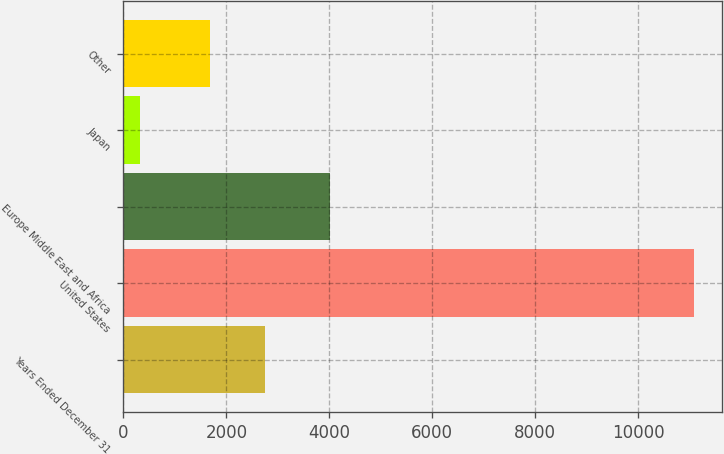Convert chart to OTSL. <chart><loc_0><loc_0><loc_500><loc_500><bar_chart><fcel>Years Ended December 31<fcel>United States<fcel>Europe Middle East and Africa<fcel>Japan<fcel>Other<nl><fcel>2751.3<fcel>11078<fcel>4014<fcel>315<fcel>1675<nl></chart> 